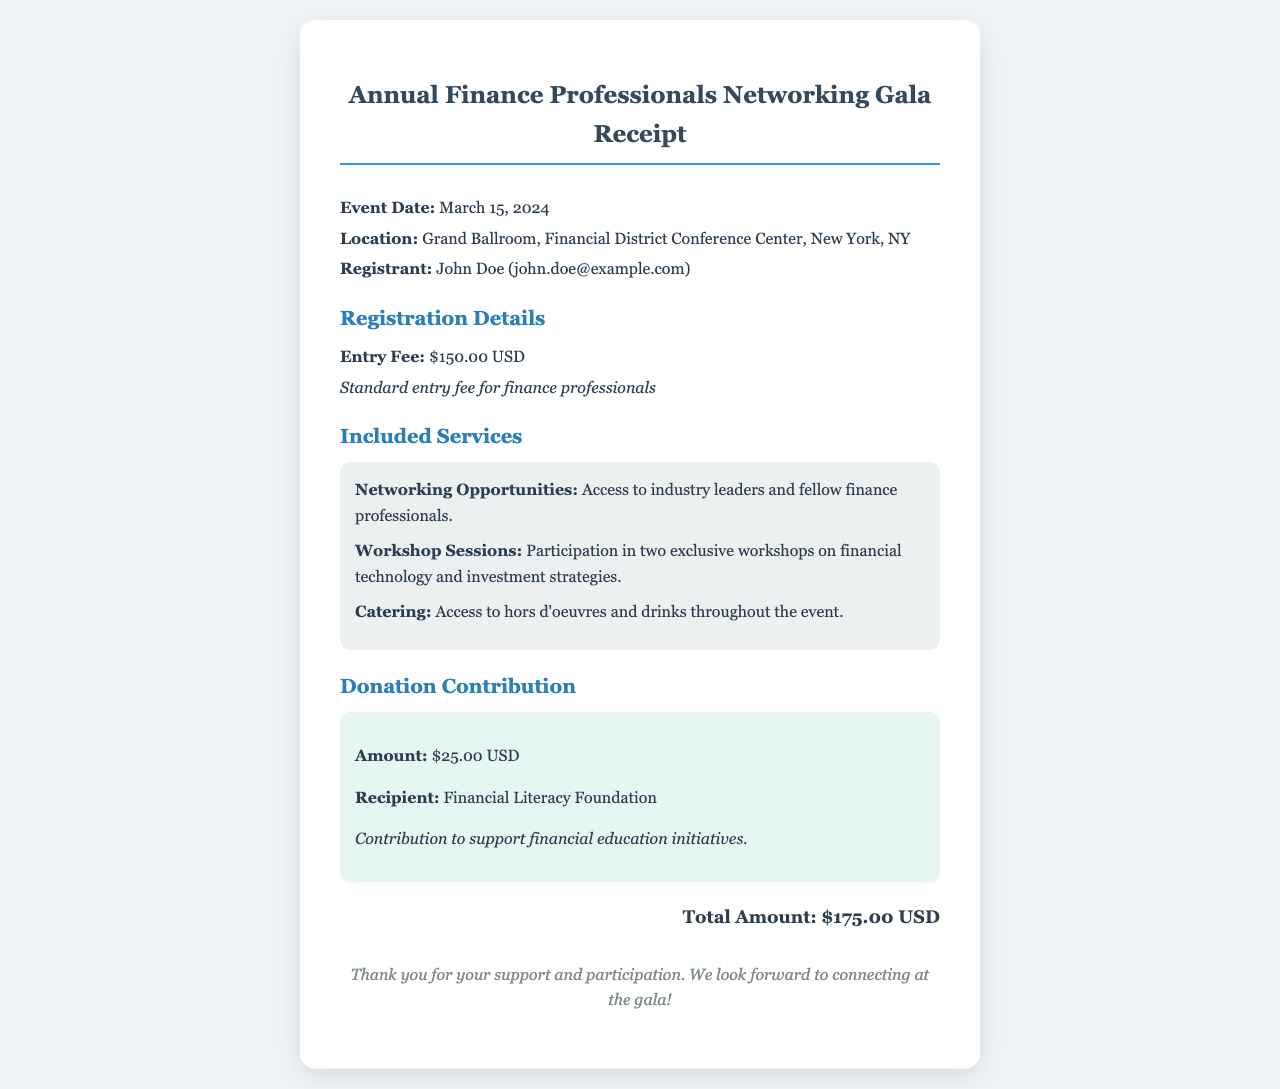What is the event date? The event date is specified in the document as March 15, 2024.
Answer: March 15, 2024 What is the entry fee? The entry fee is explicitly listed in the receipt as $150.00 USD.
Answer: $150.00 USD Who is the recipient of the donation? The document lists Financial Literacy Foundation as the recipient of the donation.
Answer: Financial Literacy Foundation How much is the donation contribution? The donation amount is stated in the document as $25.00 USD.
Answer: $25.00 USD What total amount was paid? The total amount is calculated in the receipt and presented as $175.00 USD.
Answer: $175.00 USD What type of workshops are included? The workshops mentioned include those on financial technology and investment strategies.
Answer: Financial technology and investment strategies Where is the event taking place? The location of the event is the Grand Ballroom, Financial District Conference Center, New York, NY.
Answer: Grand Ballroom, Financial District Conference Center, New York, NY What service provides access to industry leaders? Networking opportunities is the service mentioned that provides access to industry leaders and fellow finance professionals.
Answer: Networking Opportunities 